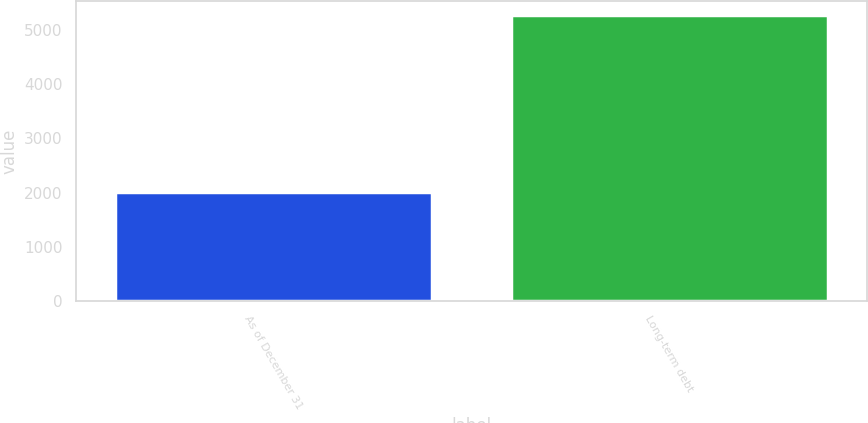Convert chart to OTSL. <chart><loc_0><loc_0><loc_500><loc_500><bar_chart><fcel>As of December 31<fcel>Long-term debt<nl><fcel>2014<fcel>5268<nl></chart> 